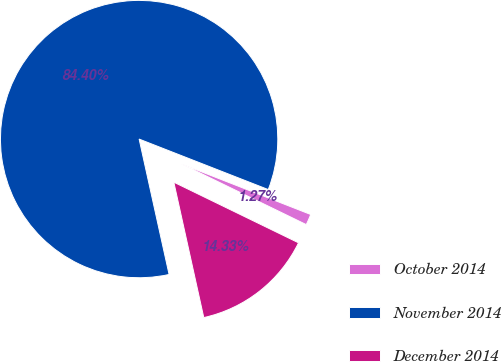Convert chart to OTSL. <chart><loc_0><loc_0><loc_500><loc_500><pie_chart><fcel>October 2014<fcel>November 2014<fcel>December 2014<nl><fcel>1.27%<fcel>84.39%<fcel>14.33%<nl></chart> 